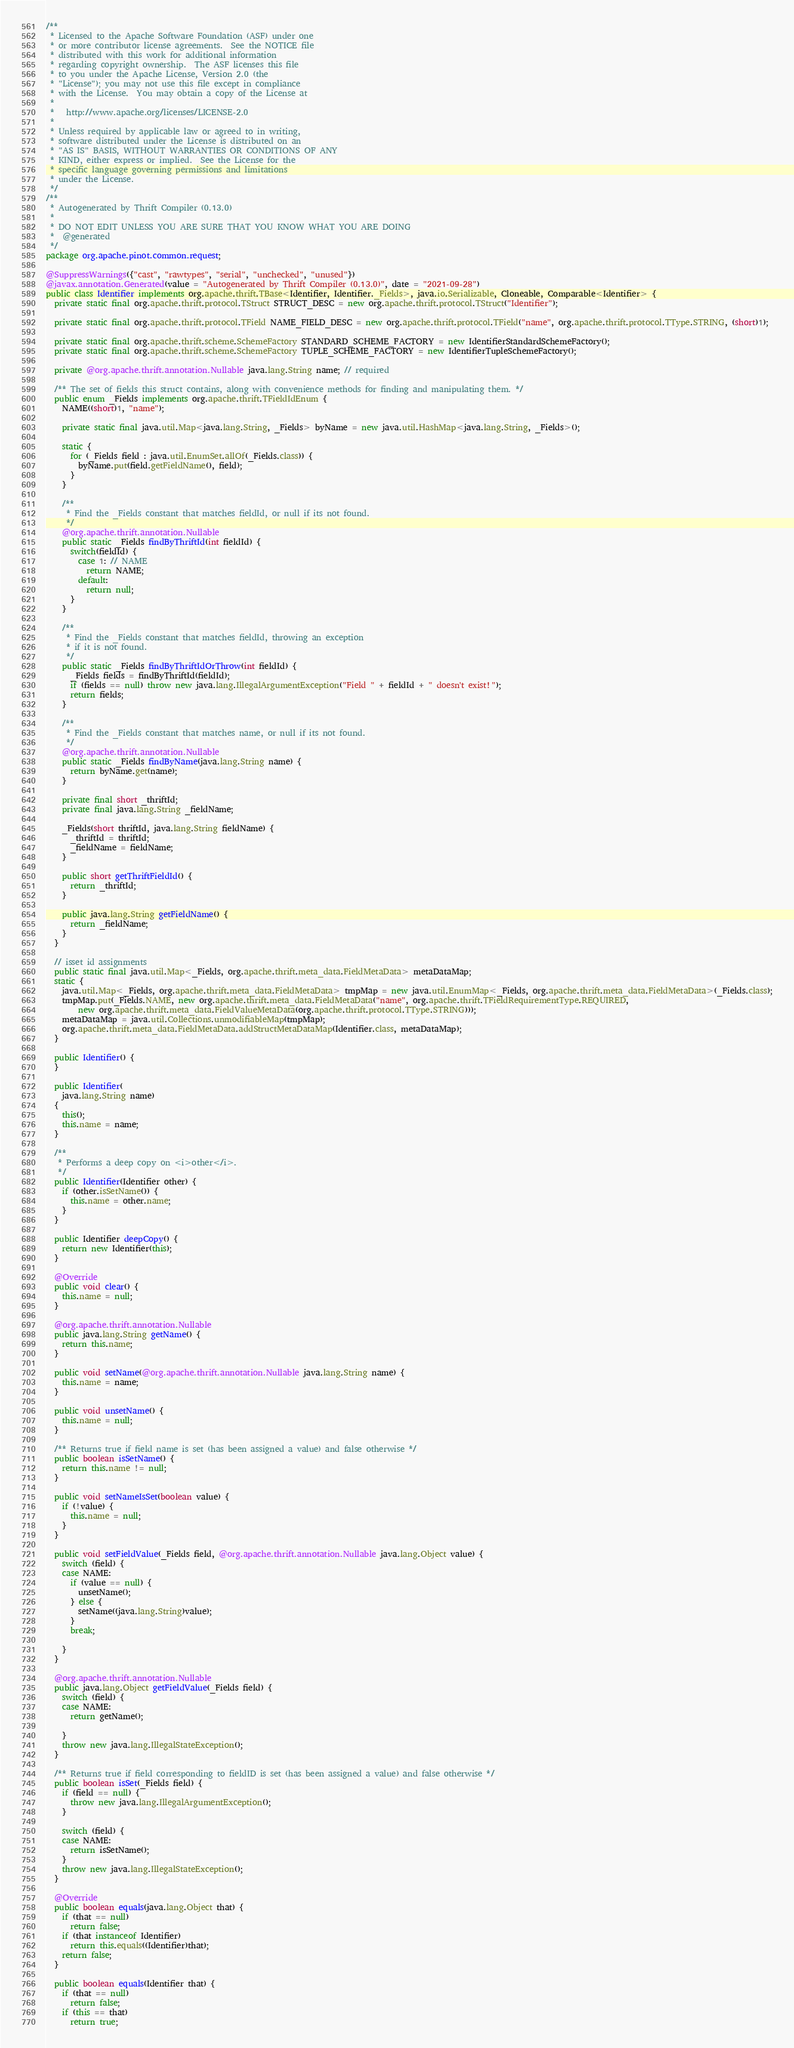<code> <loc_0><loc_0><loc_500><loc_500><_Java_>/**
 * Licensed to the Apache Software Foundation (ASF) under one
 * or more contributor license agreements.  See the NOTICE file
 * distributed with this work for additional information
 * regarding copyright ownership.  The ASF licenses this file
 * to you under the Apache License, Version 2.0 (the
 * "License"); you may not use this file except in compliance
 * with the License.  You may obtain a copy of the License at
 *
 *   http://www.apache.org/licenses/LICENSE-2.0
 *
 * Unless required by applicable law or agreed to in writing,
 * software distributed under the License is distributed on an
 * "AS IS" BASIS, WITHOUT WARRANTIES OR CONDITIONS OF ANY
 * KIND, either express or implied.  See the License for the
 * specific language governing permissions and limitations
 * under the License.
 */
/**
 * Autogenerated by Thrift Compiler (0.13.0)
 *
 * DO NOT EDIT UNLESS YOU ARE SURE THAT YOU KNOW WHAT YOU ARE DOING
 *  @generated
 */
package org.apache.pinot.common.request;

@SuppressWarnings({"cast", "rawtypes", "serial", "unchecked", "unused"})
@javax.annotation.Generated(value = "Autogenerated by Thrift Compiler (0.13.0)", date = "2021-09-28")
public class Identifier implements org.apache.thrift.TBase<Identifier, Identifier._Fields>, java.io.Serializable, Cloneable, Comparable<Identifier> {
  private static final org.apache.thrift.protocol.TStruct STRUCT_DESC = new org.apache.thrift.protocol.TStruct("Identifier");

  private static final org.apache.thrift.protocol.TField NAME_FIELD_DESC = new org.apache.thrift.protocol.TField("name", org.apache.thrift.protocol.TType.STRING, (short)1);

  private static final org.apache.thrift.scheme.SchemeFactory STANDARD_SCHEME_FACTORY = new IdentifierStandardSchemeFactory();
  private static final org.apache.thrift.scheme.SchemeFactory TUPLE_SCHEME_FACTORY = new IdentifierTupleSchemeFactory();

  private @org.apache.thrift.annotation.Nullable java.lang.String name; // required

  /** The set of fields this struct contains, along with convenience methods for finding and manipulating them. */
  public enum _Fields implements org.apache.thrift.TFieldIdEnum {
    NAME((short)1, "name");

    private static final java.util.Map<java.lang.String, _Fields> byName = new java.util.HashMap<java.lang.String, _Fields>();

    static {
      for (_Fields field : java.util.EnumSet.allOf(_Fields.class)) {
        byName.put(field.getFieldName(), field);
      }
    }

    /**
     * Find the _Fields constant that matches fieldId, or null if its not found.
     */
    @org.apache.thrift.annotation.Nullable
    public static _Fields findByThriftId(int fieldId) {
      switch(fieldId) {
        case 1: // NAME
          return NAME;
        default:
          return null;
      }
    }

    /**
     * Find the _Fields constant that matches fieldId, throwing an exception
     * if it is not found.
     */
    public static _Fields findByThriftIdOrThrow(int fieldId) {
      _Fields fields = findByThriftId(fieldId);
      if (fields == null) throw new java.lang.IllegalArgumentException("Field " + fieldId + " doesn't exist!");
      return fields;
    }

    /**
     * Find the _Fields constant that matches name, or null if its not found.
     */
    @org.apache.thrift.annotation.Nullable
    public static _Fields findByName(java.lang.String name) {
      return byName.get(name);
    }

    private final short _thriftId;
    private final java.lang.String _fieldName;

    _Fields(short thriftId, java.lang.String fieldName) {
      _thriftId = thriftId;
      _fieldName = fieldName;
    }

    public short getThriftFieldId() {
      return _thriftId;
    }

    public java.lang.String getFieldName() {
      return _fieldName;
    }
  }

  // isset id assignments
  public static final java.util.Map<_Fields, org.apache.thrift.meta_data.FieldMetaData> metaDataMap;
  static {
    java.util.Map<_Fields, org.apache.thrift.meta_data.FieldMetaData> tmpMap = new java.util.EnumMap<_Fields, org.apache.thrift.meta_data.FieldMetaData>(_Fields.class);
    tmpMap.put(_Fields.NAME, new org.apache.thrift.meta_data.FieldMetaData("name", org.apache.thrift.TFieldRequirementType.REQUIRED,
        new org.apache.thrift.meta_data.FieldValueMetaData(org.apache.thrift.protocol.TType.STRING)));
    metaDataMap = java.util.Collections.unmodifiableMap(tmpMap);
    org.apache.thrift.meta_data.FieldMetaData.addStructMetaDataMap(Identifier.class, metaDataMap);
  }

  public Identifier() {
  }

  public Identifier(
    java.lang.String name)
  {
    this();
    this.name = name;
  }

  /**
   * Performs a deep copy on <i>other</i>.
   */
  public Identifier(Identifier other) {
    if (other.isSetName()) {
      this.name = other.name;
    }
  }

  public Identifier deepCopy() {
    return new Identifier(this);
  }

  @Override
  public void clear() {
    this.name = null;
  }

  @org.apache.thrift.annotation.Nullable
  public java.lang.String getName() {
    return this.name;
  }

  public void setName(@org.apache.thrift.annotation.Nullable java.lang.String name) {
    this.name = name;
  }

  public void unsetName() {
    this.name = null;
  }

  /** Returns true if field name is set (has been assigned a value) and false otherwise */
  public boolean isSetName() {
    return this.name != null;
  }

  public void setNameIsSet(boolean value) {
    if (!value) {
      this.name = null;
    }
  }

  public void setFieldValue(_Fields field, @org.apache.thrift.annotation.Nullable java.lang.Object value) {
    switch (field) {
    case NAME:
      if (value == null) {
        unsetName();
      } else {
        setName((java.lang.String)value);
      }
      break;

    }
  }

  @org.apache.thrift.annotation.Nullable
  public java.lang.Object getFieldValue(_Fields field) {
    switch (field) {
    case NAME:
      return getName();

    }
    throw new java.lang.IllegalStateException();
  }

  /** Returns true if field corresponding to fieldID is set (has been assigned a value) and false otherwise */
  public boolean isSet(_Fields field) {
    if (field == null) {
      throw new java.lang.IllegalArgumentException();
    }

    switch (field) {
    case NAME:
      return isSetName();
    }
    throw new java.lang.IllegalStateException();
  }

  @Override
  public boolean equals(java.lang.Object that) {
    if (that == null)
      return false;
    if (that instanceof Identifier)
      return this.equals((Identifier)that);
    return false;
  }

  public boolean equals(Identifier that) {
    if (that == null)
      return false;
    if (this == that)
      return true;
</code> 